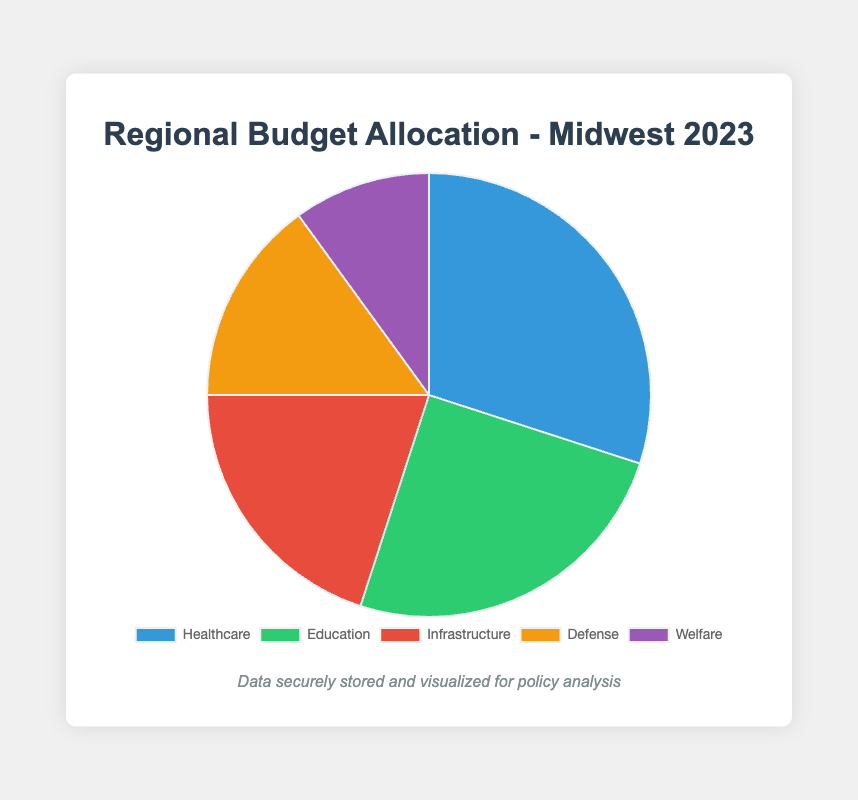What's the largest sector in regional budget allocation? The largest sector is the one with the highest percentage. According to the data, Healthcare has 30%, which is the highest.
Answer: Healthcare Which sector received the least funding? The sector with the smallest percentage in the pie chart corresponds to the least funding. Welfare has 10%, which is the least.
Answer: Welfare What are the combined allocations for Education and Infrastructure? Add the percentages for Education and Infrastructure. Education is 25%, and Infrastructure is 20%. So, 25% + 20% = 45%.
Answer: 45% How much more is allocated to Healthcare compared to Defense? Subtract Defense's percentage from Healthcare's percentage. Healthcare is at 30% and Defense at 15%. So, 30% - 15% = 15%.
Answer: 15% What fraction of the total budget is allocated to Education and Welfare combined? Add the budgets for Education and Welfare: 250 million USD (Education) + 100 million USD (Welfare) = 350 million USD. The total budget is 1 billion USD. The fraction is 350 million / 1 billion = 0.35.
Answer: 0.35 Which sector is represented by the color green in the pie chart? The sector represented by the color green can be spotted from the chart's legend. According to the color scheme, Education is colored green.
Answer: Education If the Defense allocation were increased by 5%, which sector would it equal in size? If Defense increases by 5%, its percentage becomes 20%. It would then equal the allocation for Infrastructure, which is also 20%.
Answer: Infrastructure Which two sectors combined have a total allocation of 50%? Look for sectors where the sum of percentages equals 50%. Healthcare (30%) and Welfare (10%) combined is 40%. Education (25%) and Infrastructure (20%) combined is 45%. Healthcare (30%) and Defense (15%) adds to 45%. Education (25%) and Defense (15%) combined is 40%. These do not match. However, Education (25%) and Welfare (10%) combined equals 35%, add Healthcare 30% and you get 65%. Further, Education plus Infrastructure combined equals 45%
Answer: Education and Infrastructure 